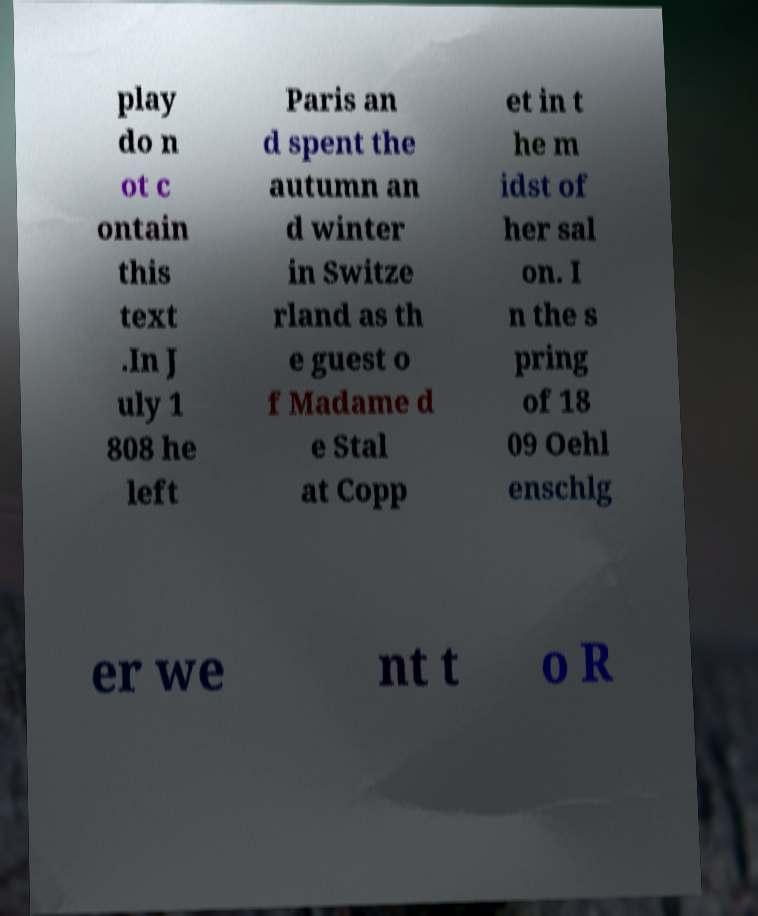What messages or text are displayed in this image? I need them in a readable, typed format. play do n ot c ontain this text .In J uly 1 808 he left Paris an d spent the autumn an d winter in Switze rland as th e guest o f Madame d e Stal at Copp et in t he m idst of her sal on. I n the s pring of 18 09 Oehl enschlg er we nt t o R 